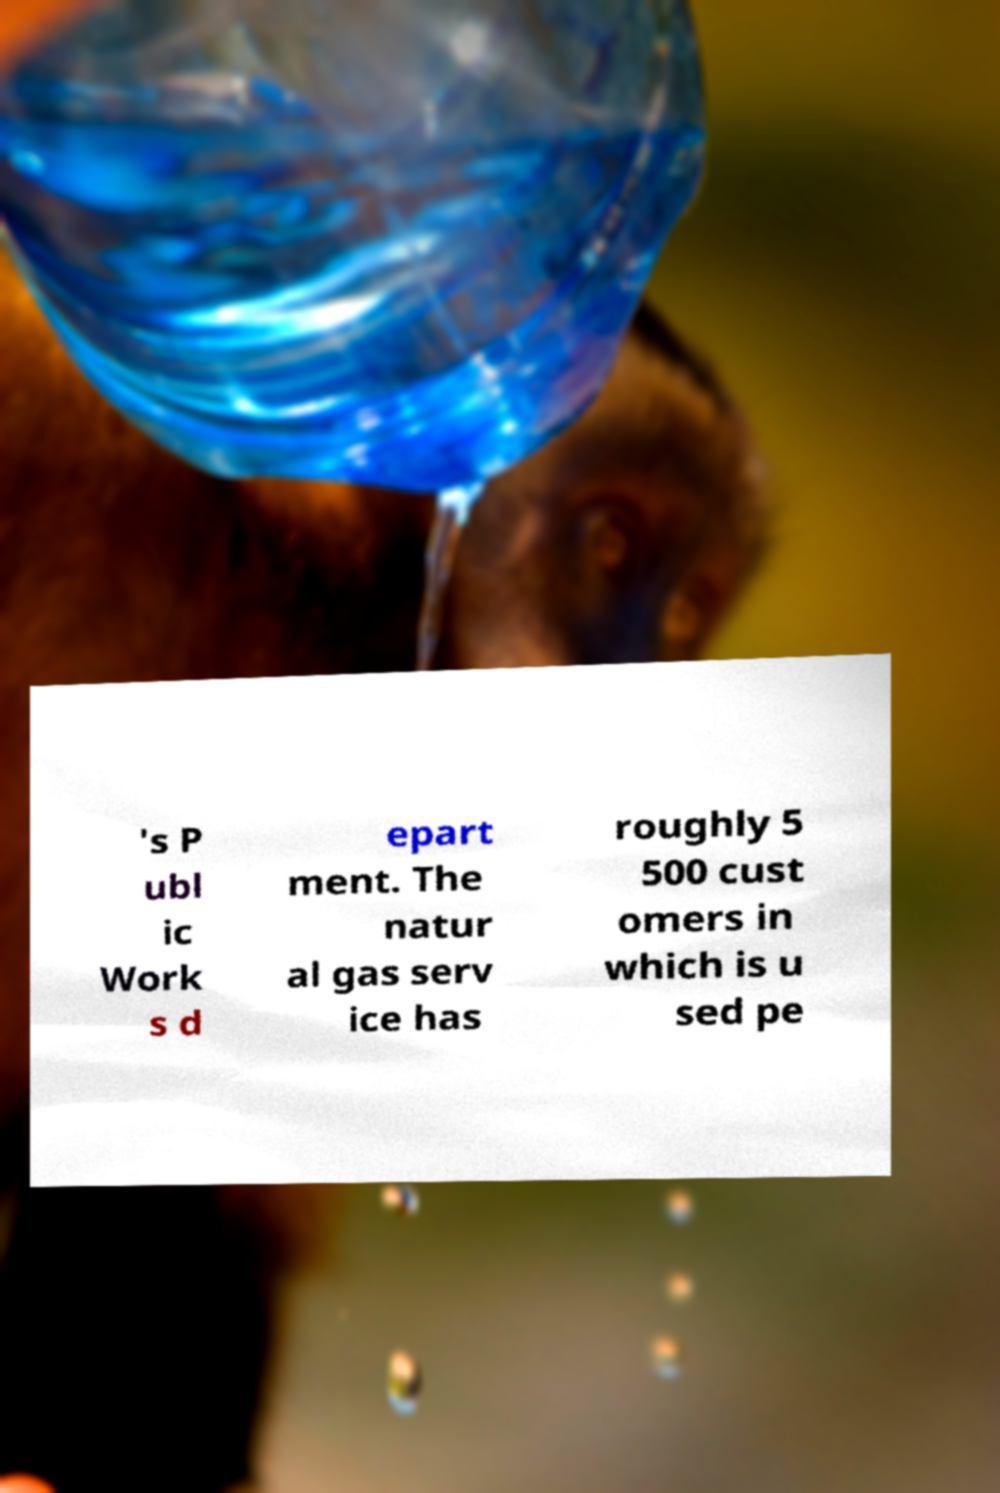Please read and relay the text visible in this image. What does it say? 's P ubl ic Work s d epart ment. The natur al gas serv ice has roughly 5 500 cust omers in which is u sed pe 